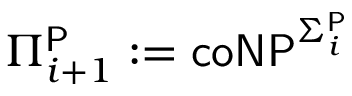<formula> <loc_0><loc_0><loc_500><loc_500>\Pi _ { i + 1 } ^ { P } \colon = { c o N P } ^ { \Sigma _ { i } ^ { P } }</formula> 